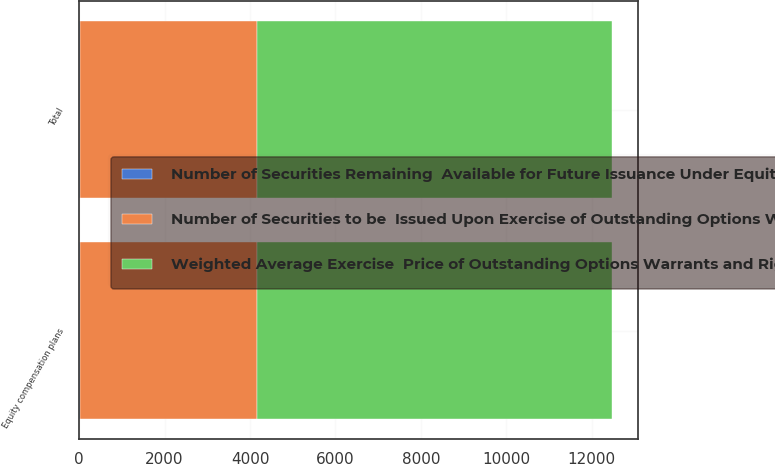Convert chart to OTSL. <chart><loc_0><loc_0><loc_500><loc_500><stacked_bar_chart><ecel><fcel>Equity compensation plans<fcel>Total<nl><fcel>Number of Securities to be  Issued Upon Exercise of Outstanding Options Warrants and Rights<fcel>4152<fcel>4152<nl><fcel>Number of Securities Remaining  Available for Future Issuance Under Equity Compensation Plans excluding securities reflected in first column<fcel>9.87<fcel>9.87<nl><fcel>Weighted Average Exercise  Price of Outstanding Options Warrants and Rights<fcel>8301<fcel>8301<nl></chart> 